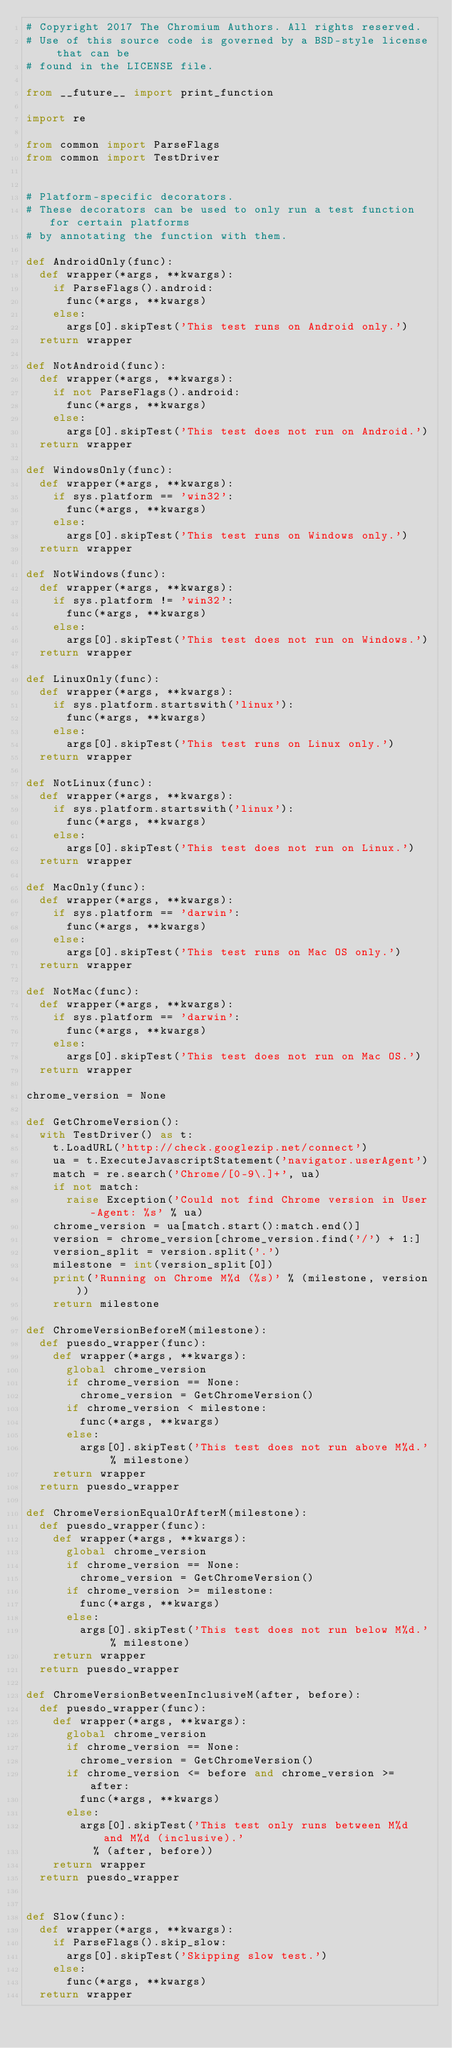<code> <loc_0><loc_0><loc_500><loc_500><_Python_># Copyright 2017 The Chromium Authors. All rights reserved.
# Use of this source code is governed by a BSD-style license that can be
# found in the LICENSE file.

from __future__ import print_function

import re

from common import ParseFlags
from common import TestDriver


# Platform-specific decorators.
# These decorators can be used to only run a test function for certain platforms
# by annotating the function with them.

def AndroidOnly(func):
  def wrapper(*args, **kwargs):
    if ParseFlags().android:
      func(*args, **kwargs)
    else:
      args[0].skipTest('This test runs on Android only.')
  return wrapper

def NotAndroid(func):
  def wrapper(*args, **kwargs):
    if not ParseFlags().android:
      func(*args, **kwargs)
    else:
      args[0].skipTest('This test does not run on Android.')
  return wrapper

def WindowsOnly(func):
  def wrapper(*args, **kwargs):
    if sys.platform == 'win32':
      func(*args, **kwargs)
    else:
      args[0].skipTest('This test runs on Windows only.')
  return wrapper

def NotWindows(func):
  def wrapper(*args, **kwargs):
    if sys.platform != 'win32':
      func(*args, **kwargs)
    else:
      args[0].skipTest('This test does not run on Windows.')
  return wrapper

def LinuxOnly(func):
  def wrapper(*args, **kwargs):
    if sys.platform.startswith('linux'):
      func(*args, **kwargs)
    else:
      args[0].skipTest('This test runs on Linux only.')
  return wrapper

def NotLinux(func):
  def wrapper(*args, **kwargs):
    if sys.platform.startswith('linux'):
      func(*args, **kwargs)
    else:
      args[0].skipTest('This test does not run on Linux.')
  return wrapper

def MacOnly(func):
  def wrapper(*args, **kwargs):
    if sys.platform == 'darwin':
      func(*args, **kwargs)
    else:
      args[0].skipTest('This test runs on Mac OS only.')
  return wrapper

def NotMac(func):
  def wrapper(*args, **kwargs):
    if sys.platform == 'darwin':
      func(*args, **kwargs)
    else:
      args[0].skipTest('This test does not run on Mac OS.')
  return wrapper

chrome_version = None

def GetChromeVersion():
  with TestDriver() as t:
    t.LoadURL('http://check.googlezip.net/connect')
    ua = t.ExecuteJavascriptStatement('navigator.userAgent')
    match = re.search('Chrome/[0-9\.]+', ua)
    if not match:
      raise Exception('Could not find Chrome version in User-Agent: %s' % ua)
    chrome_version = ua[match.start():match.end()]
    version = chrome_version[chrome_version.find('/') + 1:]
    version_split = version.split('.')
    milestone = int(version_split[0])
    print('Running on Chrome M%d (%s)' % (milestone, version))
    return milestone

def ChromeVersionBeforeM(milestone):
  def puesdo_wrapper(func):
    def wrapper(*args, **kwargs):
      global chrome_version
      if chrome_version == None:
        chrome_version = GetChromeVersion()
      if chrome_version < milestone:
        func(*args, **kwargs)
      else:
        args[0].skipTest('This test does not run above M%d.' % milestone)
    return wrapper
  return puesdo_wrapper

def ChromeVersionEqualOrAfterM(milestone):
  def puesdo_wrapper(func):
    def wrapper(*args, **kwargs):
      global chrome_version
      if chrome_version == None:
        chrome_version = GetChromeVersion()
      if chrome_version >= milestone:
        func(*args, **kwargs)
      else:
        args[0].skipTest('This test does not run below M%d.' % milestone)
    return wrapper
  return puesdo_wrapper

def ChromeVersionBetweenInclusiveM(after, before):
  def puesdo_wrapper(func):
    def wrapper(*args, **kwargs):
      global chrome_version
      if chrome_version == None:
        chrome_version = GetChromeVersion()
      if chrome_version <= before and chrome_version >= after:
        func(*args, **kwargs)
      else:
        args[0].skipTest('This test only runs between M%d and M%d (inclusive).'
          % (after, before))
    return wrapper
  return puesdo_wrapper


def Slow(func):
  def wrapper(*args, **kwargs):
    if ParseFlags().skip_slow:
      args[0].skipTest('Skipping slow test.')
    else:
      func(*args, **kwargs)
  return wrapper
</code> 